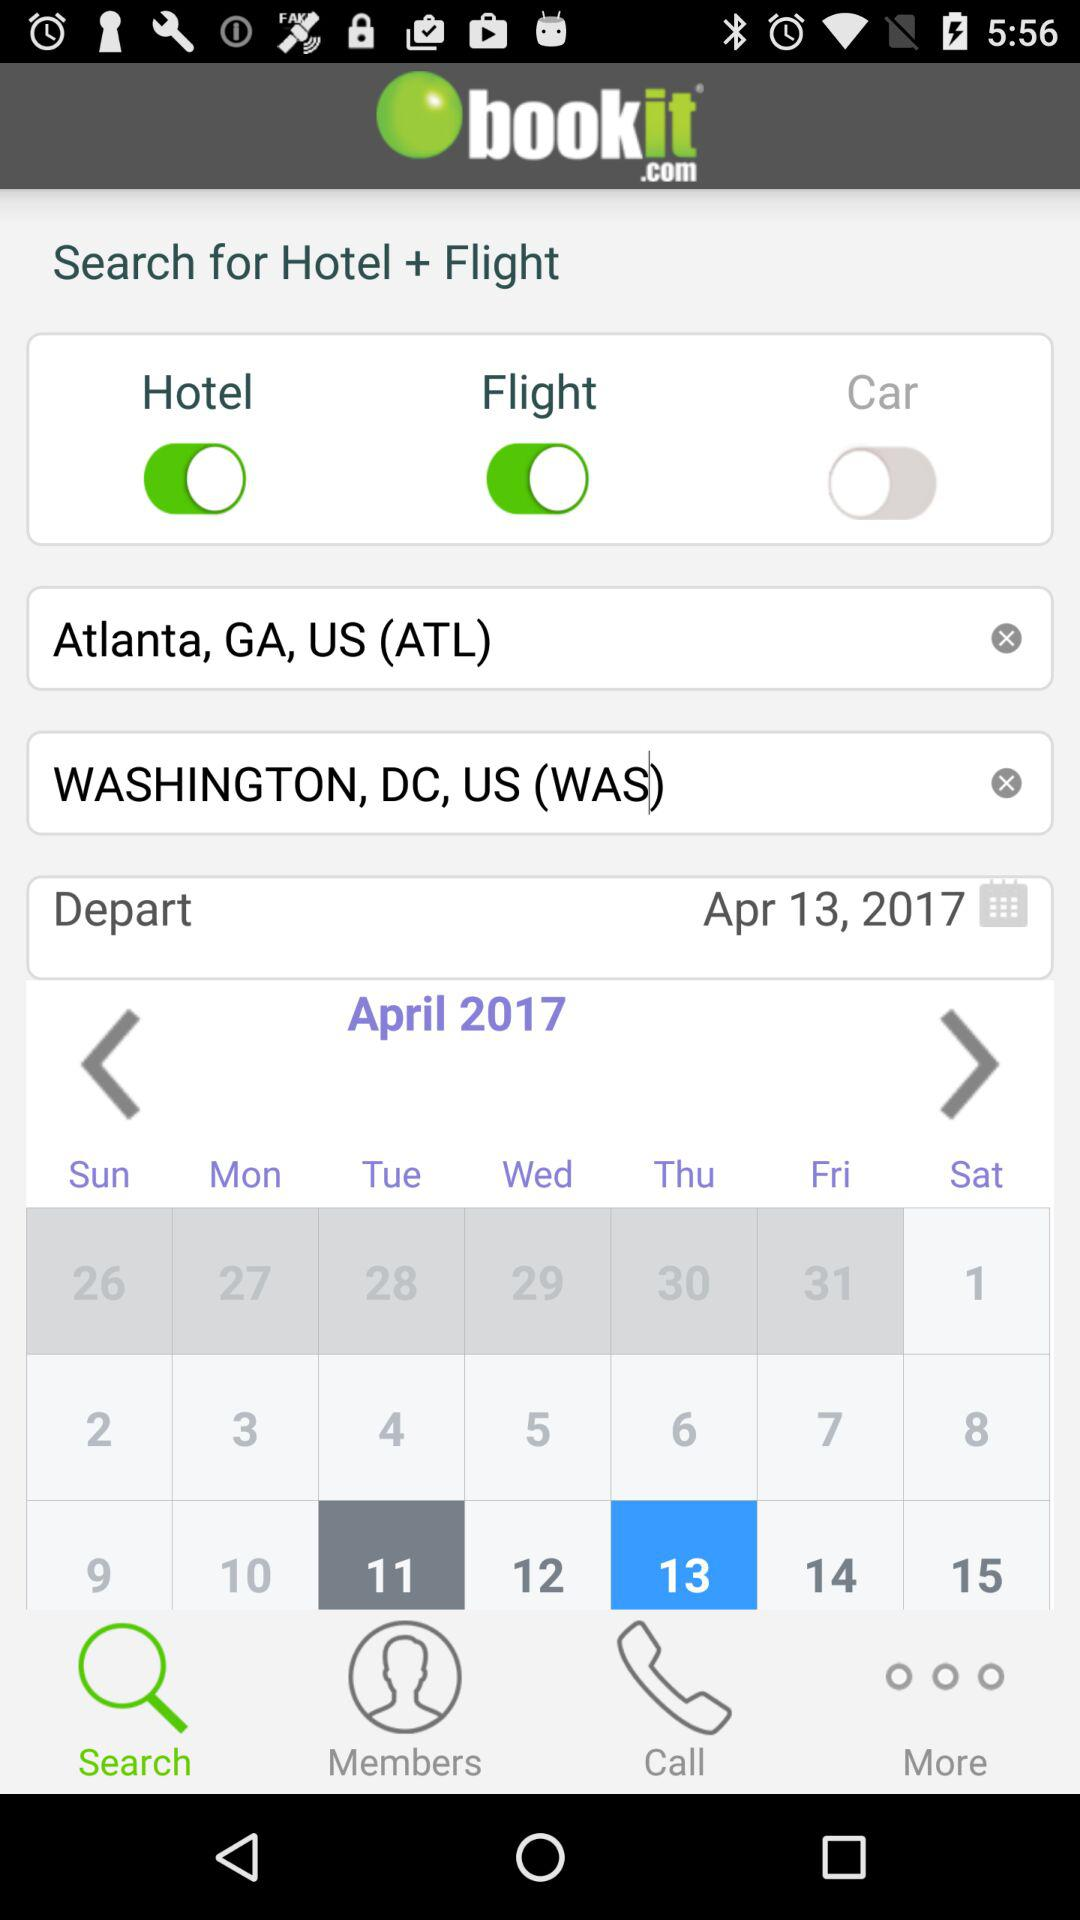Which tab am I on? You are on the "Search" tab. 